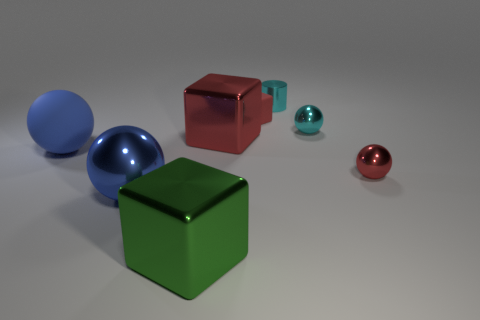What is the size of the red thing that is on the right side of the large red thing and in front of the red rubber block?
Keep it short and to the point. Small. Are there more small matte things in front of the big red object than tiny cyan metallic cylinders to the left of the blue metal object?
Provide a succinct answer. No. The sphere that is the same color as the large matte thing is what size?
Provide a short and direct response. Large. The large rubber ball has what color?
Offer a very short reply. Blue. The metal thing that is both behind the blue shiny object and in front of the blue rubber ball is what color?
Ensure brevity in your answer.  Red. There is a big metal block that is in front of the red thing right of the shiny object that is behind the red rubber object; what is its color?
Your response must be concise. Green. There is another block that is the same size as the green shiny cube; what color is it?
Your answer should be compact. Red. What is the shape of the blue shiny object that is left of the matte thing that is right of the metallic block in front of the large matte sphere?
Provide a short and direct response. Sphere. The tiny metallic object that is the same color as the cylinder is what shape?
Provide a succinct answer. Sphere. How many things are either tiny purple things or small spheres in front of the large red object?
Your answer should be very brief. 1. 